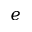Convert formula to latex. <formula><loc_0><loc_0><loc_500><loc_500>e</formula> 